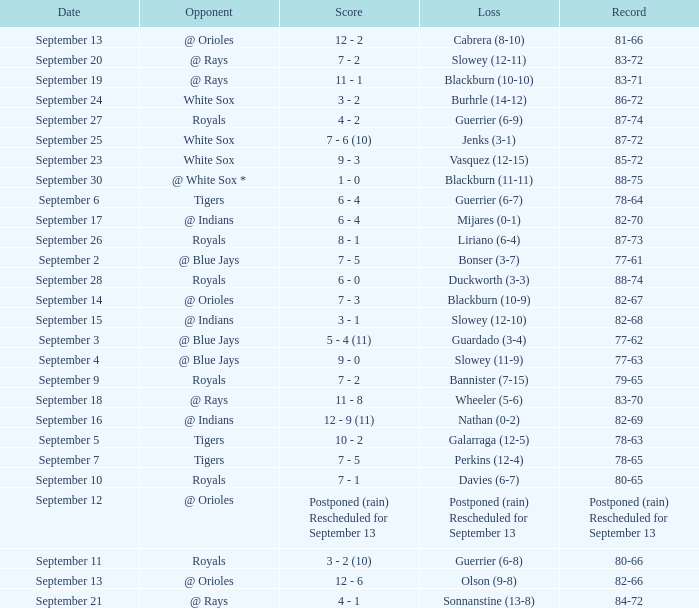What opponnent has a record of 82-68? @ Indians. 